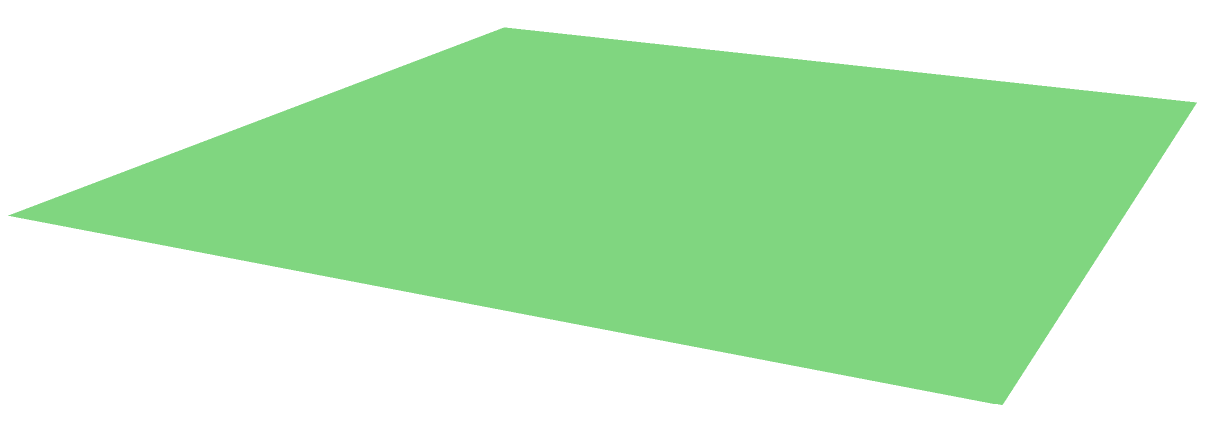A pyramidal roof structure has a square base with side length $a = 5$ m and a height $h = 4$ m. Calculate the total surface area of the roof, including the base. Round your answer to the nearest whole square meter. To find the total surface area, we need to calculate the area of the base and the lateral surface area of the pyramid.

1. Area of the base:
   $$A_{base} = a^2 = 5^2 = 25 \text{ m}^2$$

2. For the lateral surface area, we need to find the slant height (s) using the Pythagorean theorem:
   $$s^2 = (\frac{a}{2})^2 + h^2$$
   $$s^2 = (\frac{5}{2})^2 + 4^2 = 6.25 + 16 = 22.25$$
   $$s = \sqrt{22.25} \approx 4.72 \text{ m}$$

3. Area of one triangular face:
   $$A_{face} = \frac{1}{2} \times a \times s = \frac{1}{2} \times 5 \times 4.72 = 11.8 \text{ m}^2$$

4. Total lateral surface area (4 identical faces):
   $$A_{lateral} = 4 \times A_{face} = 4 \times 11.8 = 47.2 \text{ m}^2$$

5. Total surface area:
   $$A_{total} = A_{base} + A_{lateral} = 25 + 47.2 = 72.2 \text{ m}^2$$

6. Rounding to the nearest whole square meter:
   $$A_{total} \approx 72 \text{ m}^2$$
Answer: 72 m² 